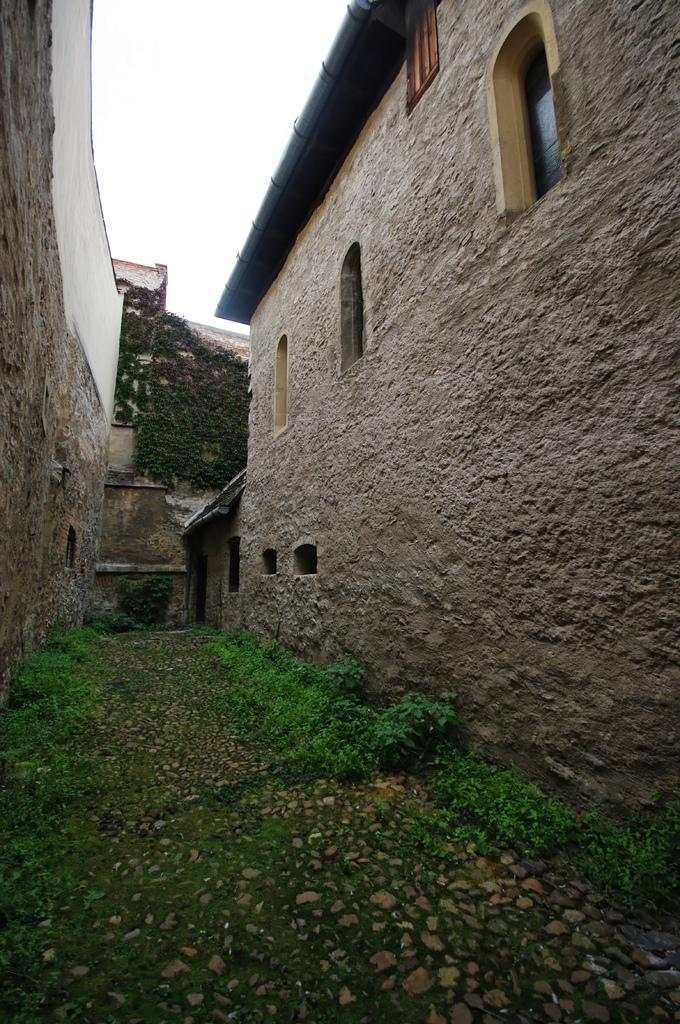What material are the buildings in the image made of? The buildings in the image are made of stone. What architectural feature can be seen in the buildings? There are windows in the buildings. What type of vegetation is visible in the image? Trees are visible in the image. What is the ground covered with in the image? Grass is present in the image. What else is visible on the ground in the image? Stones are visible in the image. What is the color of the sky in the image? The sky is white in the image. What is the position of the minute hand on the clock in the image? There is no clock present in the image, so it is not possible to determine the position of the minute hand. 